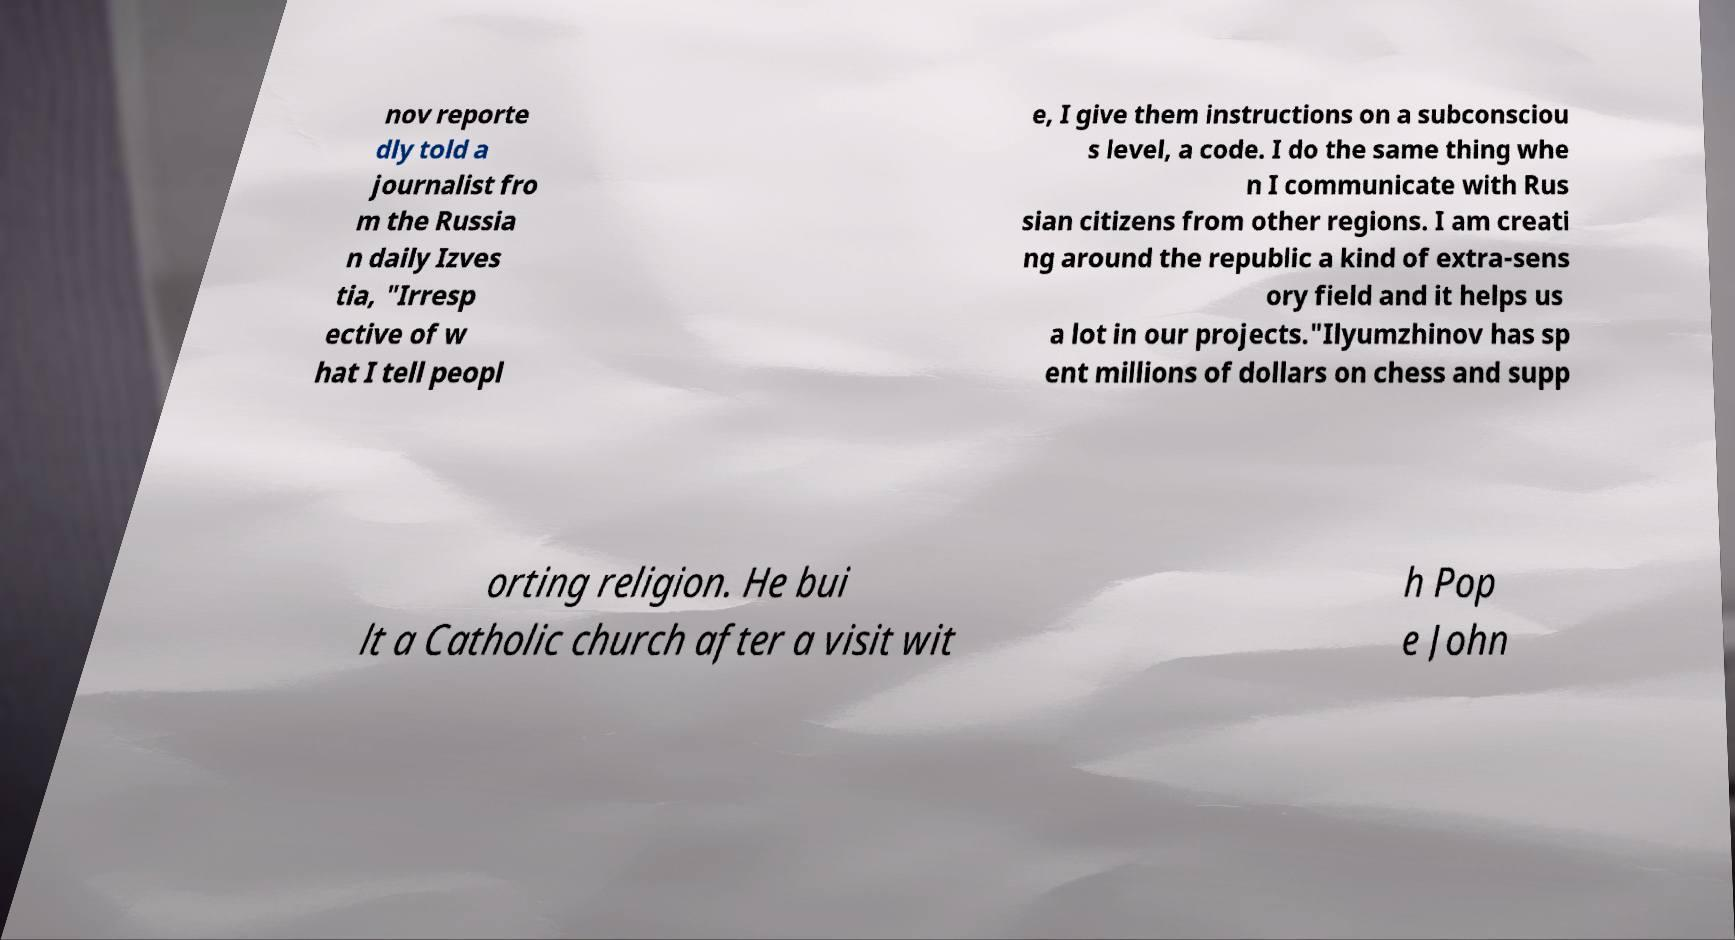Could you extract and type out the text from this image? nov reporte dly told a journalist fro m the Russia n daily Izves tia, "Irresp ective of w hat I tell peopl e, I give them instructions on a subconsciou s level, a code. I do the same thing whe n I communicate with Rus sian citizens from other regions. I am creati ng around the republic a kind of extra-sens ory field and it helps us a lot in our projects."Ilyumzhinov has sp ent millions of dollars on chess and supp orting religion. He bui lt a Catholic church after a visit wit h Pop e John 